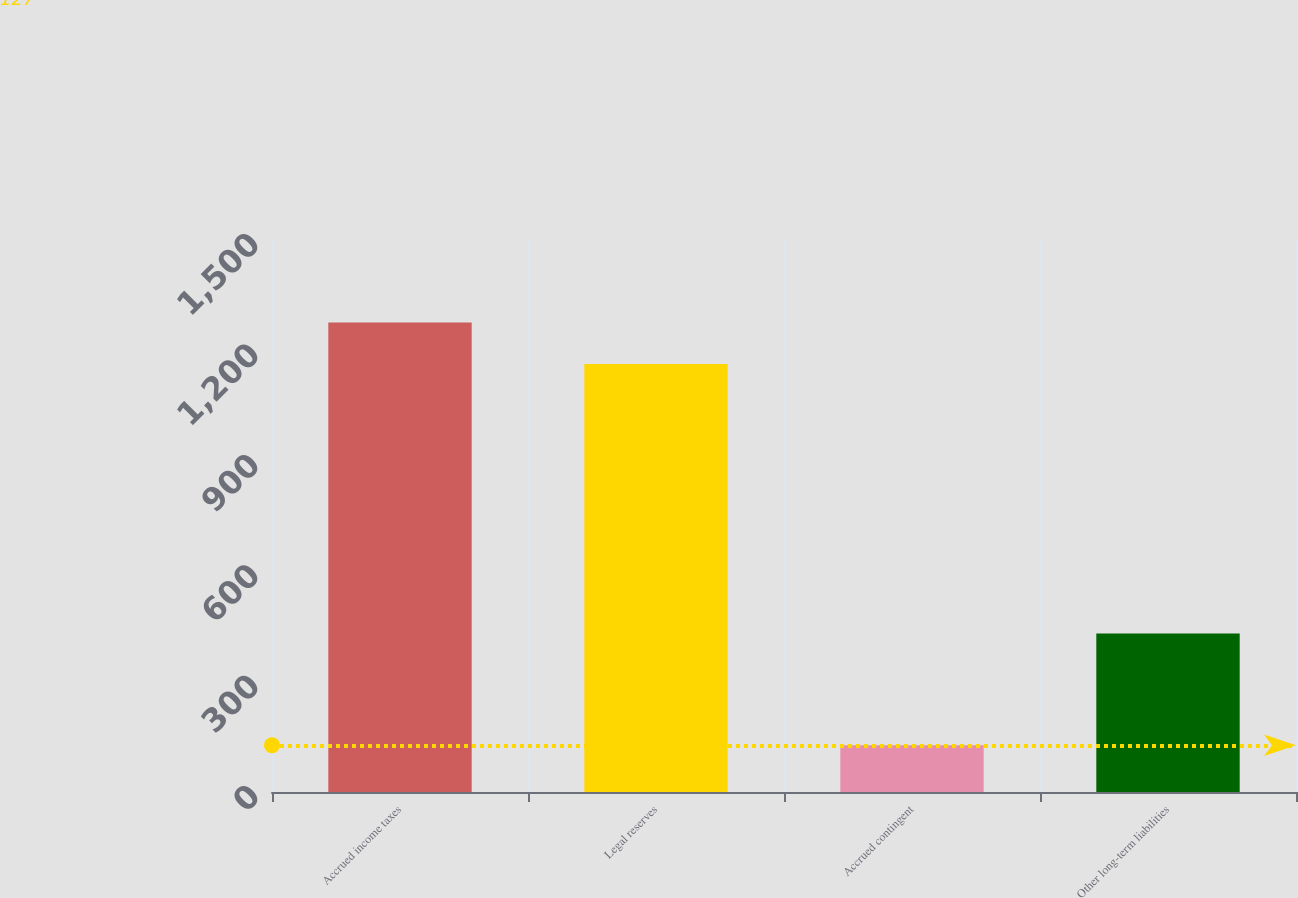<chart> <loc_0><loc_0><loc_500><loc_500><bar_chart><fcel>Accrued income taxes<fcel>Legal reserves<fcel>Accrued contingent<fcel>Other long-term liabilities<nl><fcel>1275.6<fcel>1163<fcel>127<fcel>431<nl></chart> 